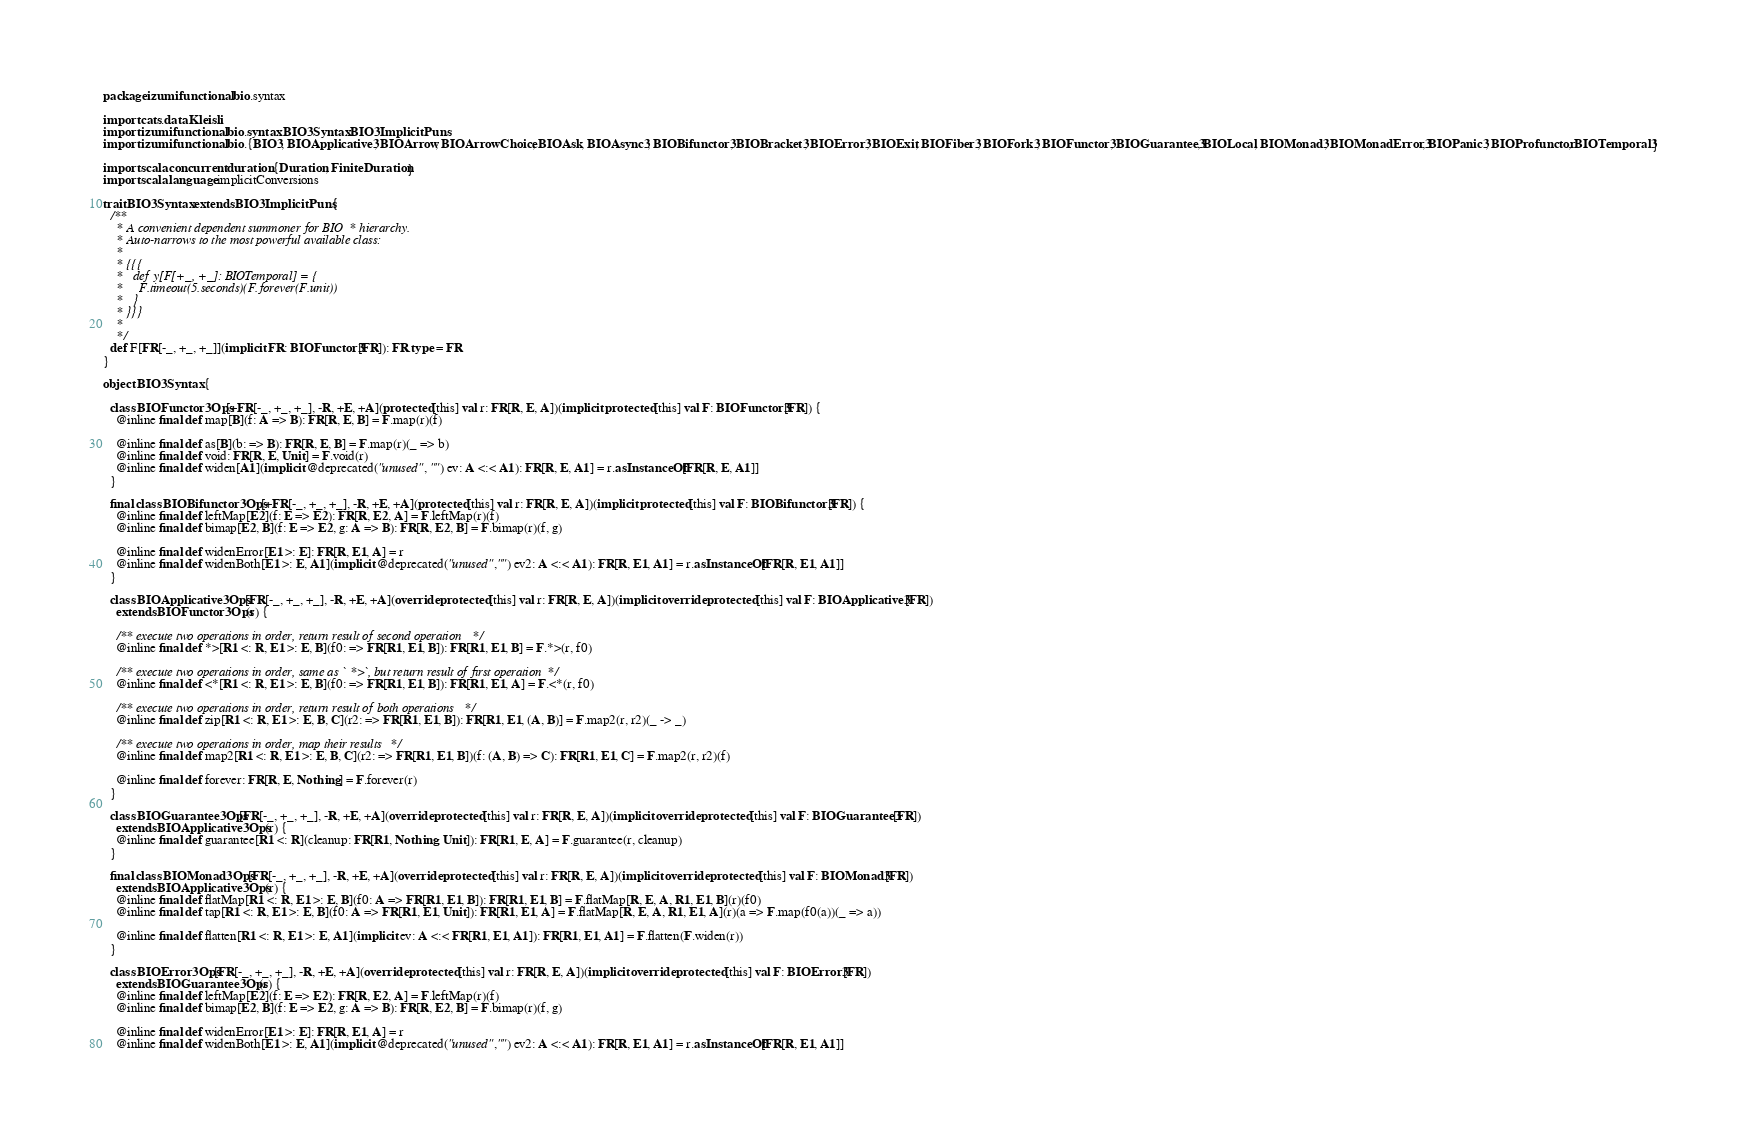<code> <loc_0><loc_0><loc_500><loc_500><_Scala_>package izumi.functional.bio.syntax

import cats.data.Kleisli
import izumi.functional.bio.syntax.BIO3Syntax.BIO3ImplicitPuns
import izumi.functional.bio.{BIO3, BIOApplicative3, BIOArrow, BIOArrowChoice, BIOAsk, BIOAsync3, BIOBifunctor3, BIOBracket3, BIOError3, BIOExit, BIOFiber3, BIOFork3, BIOFunctor3, BIOGuarantee3, BIOLocal, BIOMonad3, BIOMonadError3, BIOPanic3, BIOProfunctor, BIOTemporal3}

import scala.concurrent.duration.{Duration, FiniteDuration}
import scala.language.implicitConversions

trait BIO3Syntax extends BIO3ImplicitPuns {
  /**
    * A convenient dependent summoner for BIO* hierarchy.
    * Auto-narrows to the most powerful available class:
    *
    * {{{
    *   def y[F[+_, +_]: BIOTemporal] = {
    *     F.timeout(5.seconds)(F.forever(F.unit))
    *   }
    * }}}
    *
    */
  def F[FR[-_, +_, +_]](implicit FR: BIOFunctor3[FR]): FR.type = FR
}

object BIO3Syntax {

  class BIOFunctor3Ops[+FR[-_, +_, +_], -R, +E, +A](protected[this] val r: FR[R, E, A])(implicit protected[this] val F: BIOFunctor3[FR]) {
    @inline final def map[B](f: A => B): FR[R, E, B] = F.map(r)(f)

    @inline final def as[B](b: => B): FR[R, E, B] = F.map(r)(_ => b)
    @inline final def void: FR[R, E, Unit] = F.void(r)
    @inline final def widen[A1](implicit @deprecated("unused", "") ev: A <:< A1): FR[R, E, A1] = r.asInstanceOf[FR[R, E, A1]]
  }

  final class BIOBifunctor3Ops[+FR[-_, +_, +_], -R, +E, +A](protected[this] val r: FR[R, E, A])(implicit protected[this] val F: BIOBifunctor3[FR]) {
    @inline final def leftMap[E2](f: E => E2): FR[R, E2, A] = F.leftMap(r)(f)
    @inline final def bimap[E2, B](f: E => E2, g: A => B): FR[R, E2, B] = F.bimap(r)(f, g)

    @inline final def widenError[E1 >: E]: FR[R, E1, A] = r
    @inline final def widenBoth[E1 >: E, A1](implicit @deprecated("unused","") ev2: A <:< A1): FR[R, E1, A1] = r.asInstanceOf[FR[R, E1, A1]]
  }

  class BIOApplicative3Ops[FR[-_, +_, +_], -R, +E, +A](override protected[this] val r: FR[R, E, A])(implicit override protected[this] val F: BIOApplicative3[FR])
    extends BIOFunctor3Ops(r) {

    /** execute two operations in order, return result of second operation */
    @inline final def *>[R1 <: R, E1 >: E, B](f0: => FR[R1, E1, B]): FR[R1, E1, B] = F.*>(r, f0)

    /** execute two operations in order, same as `*>`, but return result of first operation */
    @inline final def <*[R1 <: R, E1 >: E, B](f0: => FR[R1, E1, B]): FR[R1, E1, A] = F.<*(r, f0)

    /** execute two operations in order, return result of both operations */
    @inline final def zip[R1 <: R, E1 >: E, B, C](r2: => FR[R1, E1, B]): FR[R1, E1, (A, B)] = F.map2(r, r2)(_ -> _)

    /** execute two operations in order, map their results */
    @inline final def map2[R1 <: R, E1 >: E, B, C](r2: => FR[R1, E1, B])(f: (A, B) => C): FR[R1, E1, C] = F.map2(r, r2)(f)

    @inline final def forever: FR[R, E, Nothing] = F.forever(r)
  }

  class BIOGuarantee3Ops[FR[-_, +_, +_], -R, +E, +A](override protected[this] val r: FR[R, E, A])(implicit override protected[this] val F: BIOGuarantee3[FR])
    extends BIOApplicative3Ops(r) {
    @inline final def guarantee[R1 <: R](cleanup: FR[R1, Nothing, Unit]): FR[R1, E, A] = F.guarantee(r, cleanup)
  }

  final class BIOMonad3Ops[FR[-_, +_, +_], -R, +E, +A](override protected[this] val r: FR[R, E, A])(implicit override protected[this] val F: BIOMonad3[FR])
    extends BIOApplicative3Ops(r) {
    @inline final def flatMap[R1 <: R, E1 >: E, B](f0: A => FR[R1, E1, B]): FR[R1, E1, B] = F.flatMap[R, E, A, R1, E1, B](r)(f0)
    @inline final def tap[R1 <: R, E1 >: E, B](f0: A => FR[R1, E1, Unit]): FR[R1, E1, A] = F.flatMap[R, E, A, R1, E1, A](r)(a => F.map(f0(a))(_ => a))

    @inline final def flatten[R1 <: R, E1 >: E, A1](implicit ev: A <:< FR[R1, E1, A1]): FR[R1, E1, A1] = F.flatten(F.widen(r))
  }

  class BIOError3Ops[FR[-_, +_, +_], -R, +E, +A](override protected[this] val r: FR[R, E, A])(implicit override protected[this] val F: BIOError3[FR])
    extends BIOGuarantee3Ops(r) {
    @inline final def leftMap[E2](f: E => E2): FR[R, E2, A] = F.leftMap(r)(f)
    @inline final def bimap[E2, B](f: E => E2, g: A => B): FR[R, E2, B] = F.bimap(r)(f, g)

    @inline final def widenError[E1 >: E]: FR[R, E1, A] = r
    @inline final def widenBoth[E1 >: E, A1](implicit @deprecated("unused","") ev2: A <:< A1): FR[R, E1, A1] = r.asInstanceOf[FR[R, E1, A1]]
</code> 